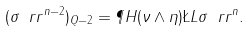<formula> <loc_0><loc_0><loc_500><loc_500>( \sigma \ r r ^ { n - 2 } ) _ { Q - 2 } = \P H ( \nu \wedge \eta ) \L L \sigma \ r r ^ { n } .</formula> 